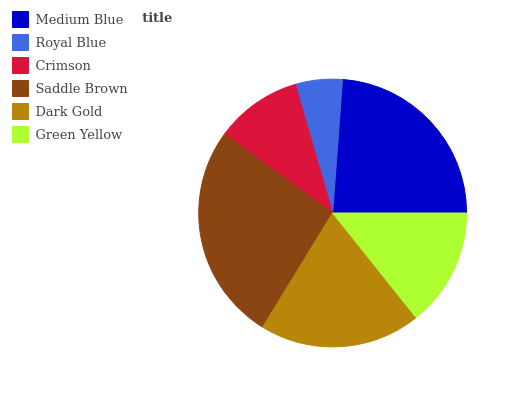Is Royal Blue the minimum?
Answer yes or no. Yes. Is Saddle Brown the maximum?
Answer yes or no. Yes. Is Crimson the minimum?
Answer yes or no. No. Is Crimson the maximum?
Answer yes or no. No. Is Crimson greater than Royal Blue?
Answer yes or no. Yes. Is Royal Blue less than Crimson?
Answer yes or no. Yes. Is Royal Blue greater than Crimson?
Answer yes or no. No. Is Crimson less than Royal Blue?
Answer yes or no. No. Is Dark Gold the high median?
Answer yes or no. Yes. Is Green Yellow the low median?
Answer yes or no. Yes. Is Royal Blue the high median?
Answer yes or no. No. Is Dark Gold the low median?
Answer yes or no. No. 